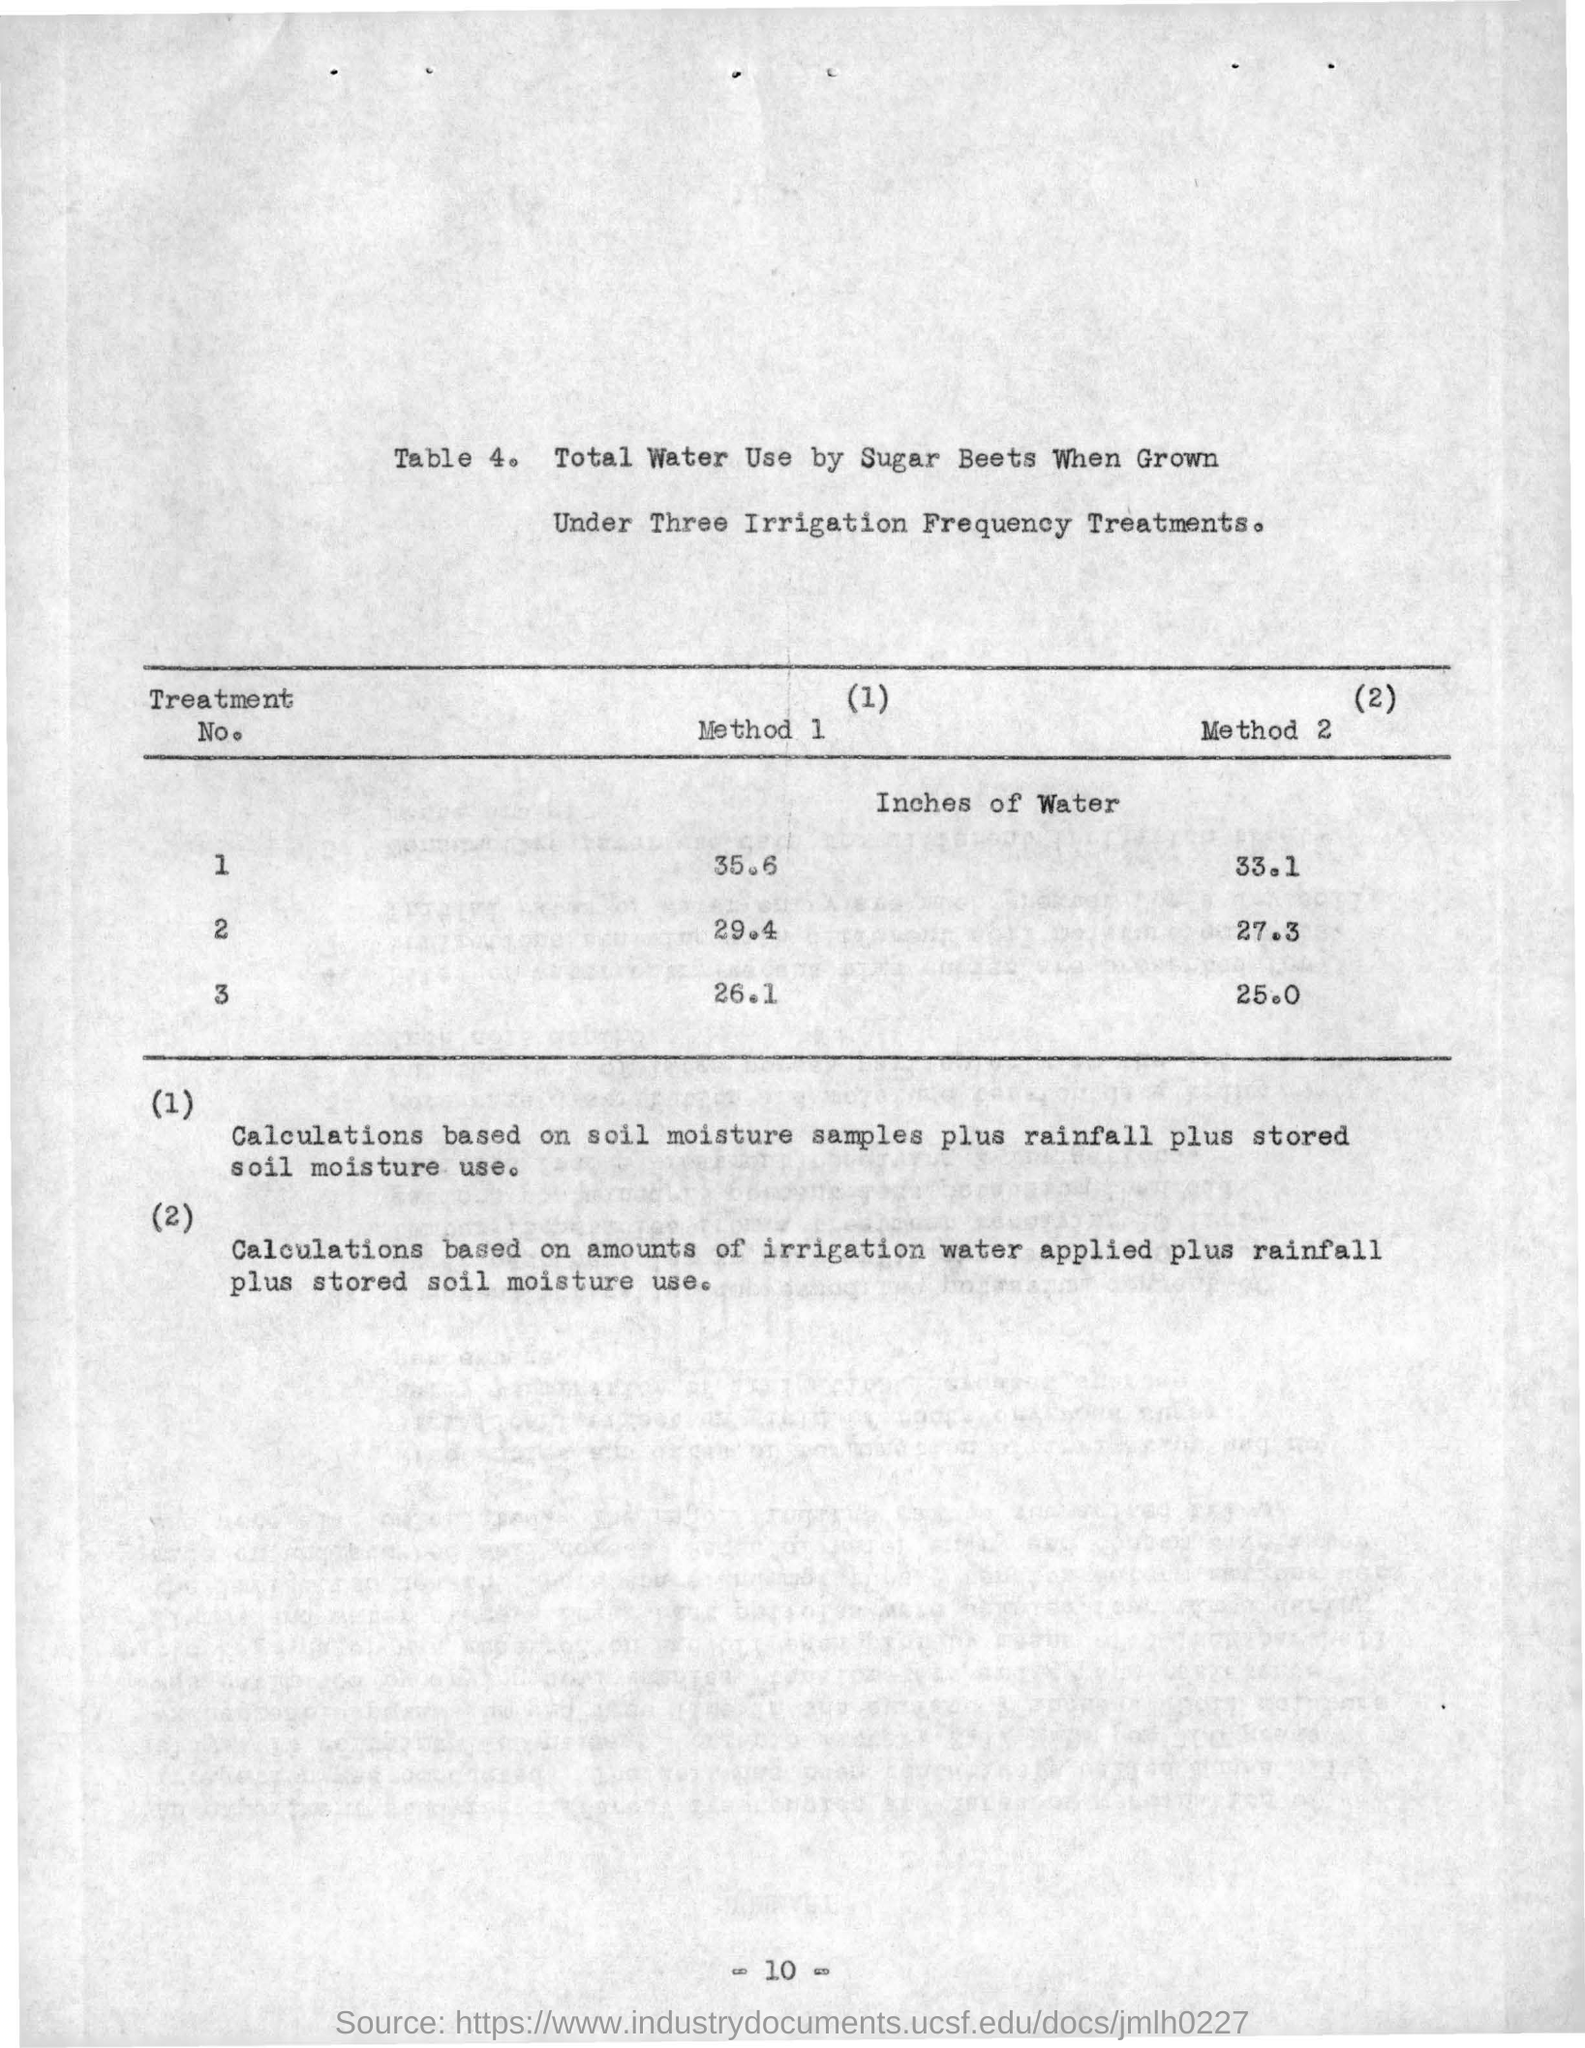Give some essential details in this illustration. There are two methods included in this table. The text you provided is a question asking for the table number, followed by a description of the table in question. 